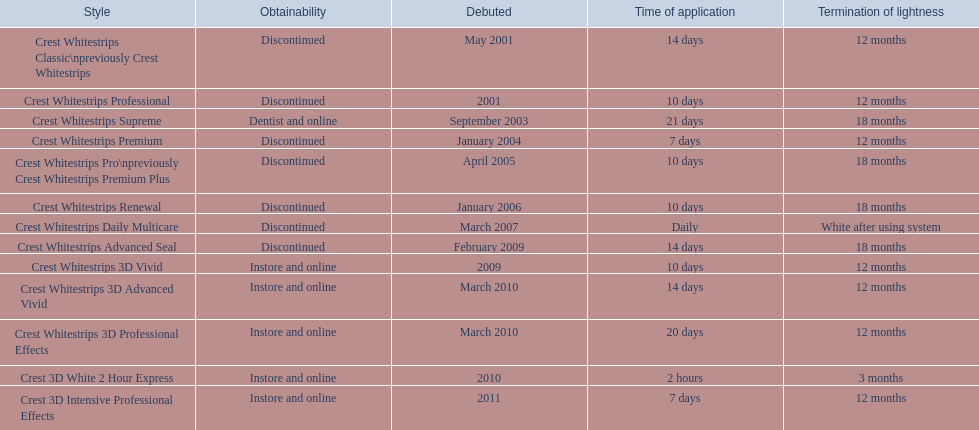Which models are still available? Crest Whitestrips Supreme, Crest Whitestrips 3D Vivid, Crest Whitestrips 3D Advanced Vivid, Crest Whitestrips 3D Professional Effects, Crest 3D White 2 Hour Express, Crest 3D Intensive Professional Effects. Of those, which were introduced prior to 2011? Crest Whitestrips Supreme, Crest Whitestrips 3D Vivid, Crest Whitestrips 3D Advanced Vivid, Crest Whitestrips 3D Professional Effects, Crest 3D White 2 Hour Express. Among those models, which ones had to be used at least 14 days? Crest Whitestrips Supreme, Crest Whitestrips 3D Advanced Vivid, Crest Whitestrips 3D Professional Effects. Which of those lasted longer than 12 months? Crest Whitestrips Supreme. 